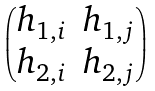Convert formula to latex. <formula><loc_0><loc_0><loc_500><loc_500>\begin{pmatrix} h _ { 1 , i } & h _ { 1 , j } \\ h _ { 2 , i } & h _ { 2 , j } \\ \end{pmatrix}</formula> 